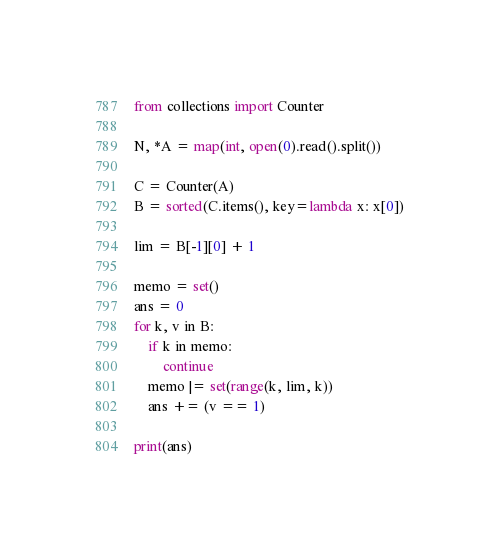<code> <loc_0><loc_0><loc_500><loc_500><_Python_>from collections import Counter

N, *A = map(int, open(0).read().split())

C = Counter(A)
B = sorted(C.items(), key=lambda x: x[0])

lim = B[-1][0] + 1

memo = set()
ans = 0
for k, v in B:
    if k in memo:
        continue
    memo |= set(range(k, lim, k))
    ans += (v == 1)

print(ans)</code> 